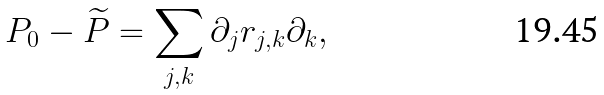Convert formula to latex. <formula><loc_0><loc_0><loc_500><loc_500>P _ { 0 } - \widetilde { P } = \sum _ { j , k } \partial _ { j } r _ { j , k } \partial _ { k } ,</formula> 